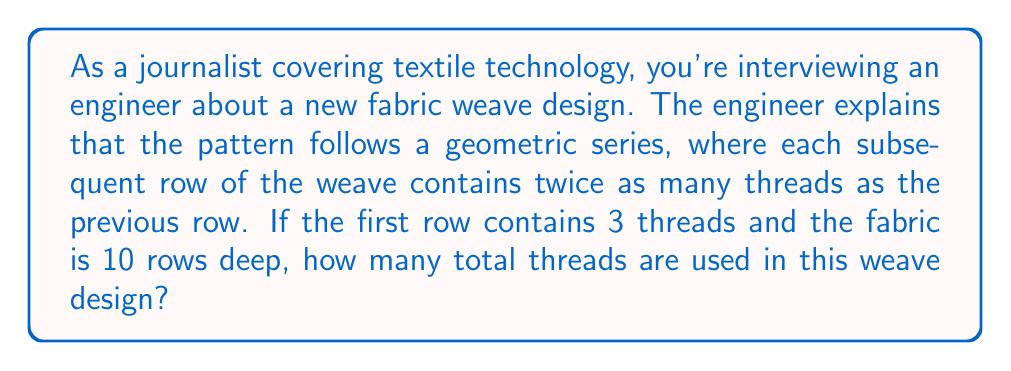Provide a solution to this math problem. Let's approach this step-by-step:

1) We're dealing with a geometric series where:
   - The first term, $a = 3$ (threads in the first row)
   - The common ratio, $r = 2$ (each row has twice as many threads as the previous)
   - The number of terms, $n = 10$ (10 rows deep)

2) The formula for the sum of a geometric series is:

   $$S_n = \frac{a(1-r^n)}{1-r}$$

   Where $S_n$ is the sum of the series, $a$ is the first term, $r$ is the common ratio, and $n$ is the number of terms.

3) Let's substitute our values:

   $$S_{10} = \frac{3(1-2^{10})}{1-2}$$

4) Simplify:
   $$S_{10} = \frac{3(1-1024)}{-1}$$
   $$S_{10} = \frac{3(-1023)}{-1}$$
   $$S_{10} = 3069$$

Therefore, the total number of threads used in this 10-row weave design is 3069.
Answer: 3069 threads 